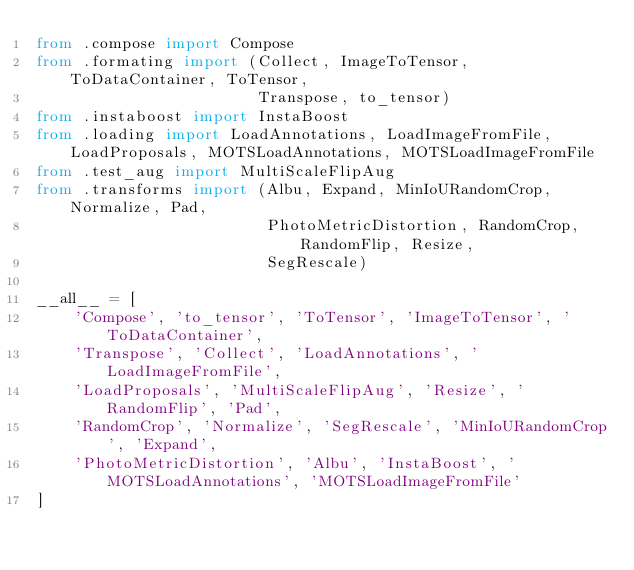<code> <loc_0><loc_0><loc_500><loc_500><_Python_>from .compose import Compose
from .formating import (Collect, ImageToTensor, ToDataContainer, ToTensor,
                        Transpose, to_tensor)
from .instaboost import InstaBoost
from .loading import LoadAnnotations, LoadImageFromFile, LoadProposals, MOTSLoadAnnotations, MOTSLoadImageFromFile
from .test_aug import MultiScaleFlipAug
from .transforms import (Albu, Expand, MinIoURandomCrop, Normalize, Pad,
                         PhotoMetricDistortion, RandomCrop, RandomFlip, Resize,
                         SegRescale)

__all__ = [
    'Compose', 'to_tensor', 'ToTensor', 'ImageToTensor', 'ToDataContainer',
    'Transpose', 'Collect', 'LoadAnnotations', 'LoadImageFromFile',
    'LoadProposals', 'MultiScaleFlipAug', 'Resize', 'RandomFlip', 'Pad',
    'RandomCrop', 'Normalize', 'SegRescale', 'MinIoURandomCrop', 'Expand',
    'PhotoMetricDistortion', 'Albu', 'InstaBoost', 'MOTSLoadAnnotations', 'MOTSLoadImageFromFile'
]
</code> 